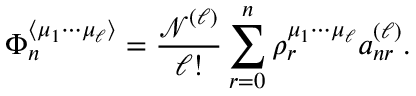<formula> <loc_0><loc_0><loc_500><loc_500>\Phi _ { n } ^ { \langle \mu _ { 1 } \cdots \mu _ { \ell } \rangle } = \frac { \mathcal { N } ^ { ( \ell ) } } { \ell ! } \sum _ { r = 0 } ^ { n } \rho _ { r } ^ { \mu _ { 1 } \cdots \mu _ { \ell } } a _ { n r } ^ { ( \ell ) } .</formula> 